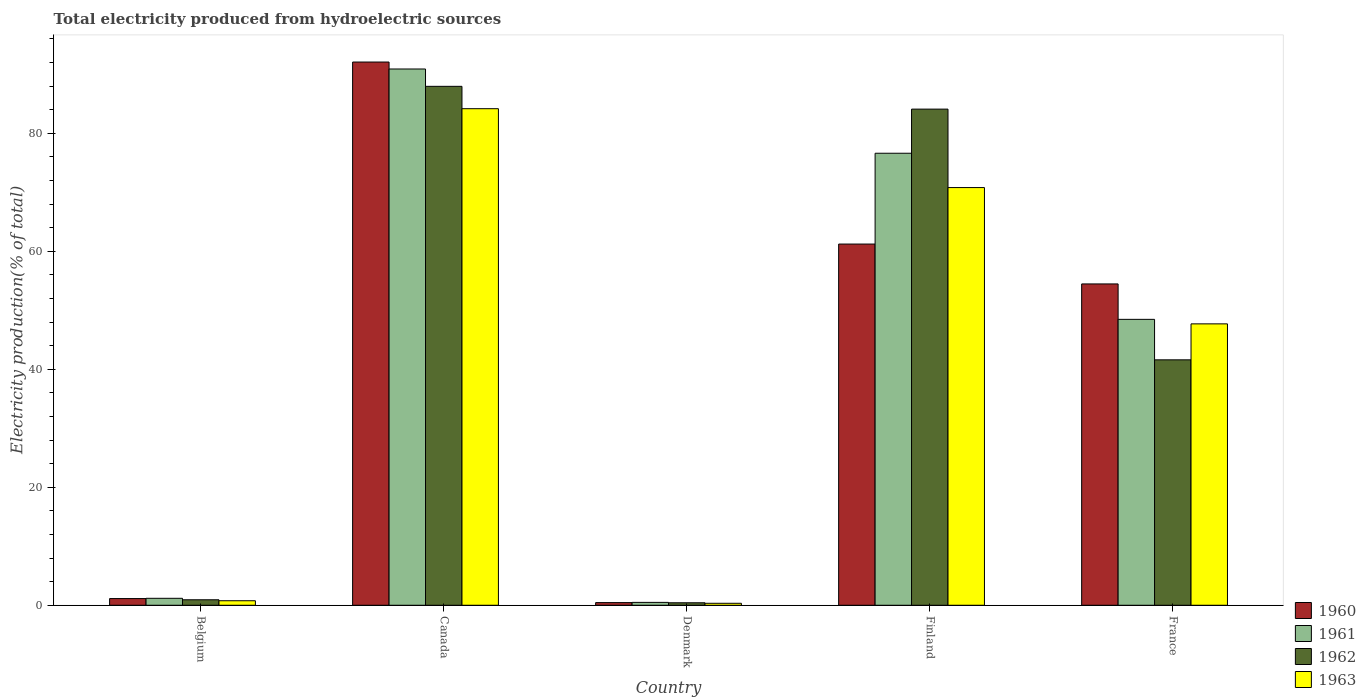How many different coloured bars are there?
Offer a terse response. 4. How many groups of bars are there?
Keep it short and to the point. 5. Are the number of bars on each tick of the X-axis equal?
Give a very brief answer. Yes. How many bars are there on the 1st tick from the right?
Ensure brevity in your answer.  4. What is the total electricity produced in 1963 in Finland?
Your answer should be very brief. 70.81. Across all countries, what is the maximum total electricity produced in 1962?
Provide a short and direct response. 87.97. Across all countries, what is the minimum total electricity produced in 1962?
Offer a very short reply. 0.42. In which country was the total electricity produced in 1961 maximum?
Your answer should be very brief. Canada. In which country was the total electricity produced in 1963 minimum?
Make the answer very short. Denmark. What is the total total electricity produced in 1960 in the graph?
Your response must be concise. 209.38. What is the difference between the total electricity produced in 1961 in Belgium and that in France?
Keep it short and to the point. -47.29. What is the difference between the total electricity produced in 1960 in Denmark and the total electricity produced in 1963 in Canada?
Your answer should be compact. -83.73. What is the average total electricity produced in 1962 per country?
Offer a very short reply. 43.01. What is the difference between the total electricity produced of/in 1962 and total electricity produced of/in 1961 in France?
Keep it short and to the point. -6.86. In how many countries, is the total electricity produced in 1963 greater than 72 %?
Your answer should be compact. 1. What is the ratio of the total electricity produced in 1961 in Canada to that in Finland?
Ensure brevity in your answer.  1.19. What is the difference between the highest and the second highest total electricity produced in 1962?
Offer a terse response. -42.5. What is the difference between the highest and the lowest total electricity produced in 1960?
Your answer should be compact. 91.64. In how many countries, is the total electricity produced in 1961 greater than the average total electricity produced in 1961 taken over all countries?
Provide a succinct answer. 3. Is the sum of the total electricity produced in 1961 in Canada and Denmark greater than the maximum total electricity produced in 1963 across all countries?
Offer a very short reply. Yes. Is it the case that in every country, the sum of the total electricity produced in 1961 and total electricity produced in 1962 is greater than the sum of total electricity produced in 1963 and total electricity produced in 1960?
Your answer should be compact. No. What does the 3rd bar from the left in Canada represents?
Make the answer very short. 1962. What does the 4th bar from the right in Finland represents?
Keep it short and to the point. 1960. Is it the case that in every country, the sum of the total electricity produced in 1960 and total electricity produced in 1962 is greater than the total electricity produced in 1963?
Offer a terse response. Yes. Does the graph contain grids?
Your response must be concise. No. How many legend labels are there?
Provide a succinct answer. 4. What is the title of the graph?
Ensure brevity in your answer.  Total electricity produced from hydroelectric sources. Does "1998" appear as one of the legend labels in the graph?
Keep it short and to the point. No. What is the Electricity production(% of total) in 1960 in Belgium?
Your answer should be compact. 1.14. What is the Electricity production(% of total) in 1961 in Belgium?
Make the answer very short. 1.18. What is the Electricity production(% of total) of 1962 in Belgium?
Offer a very short reply. 0.93. What is the Electricity production(% of total) in 1963 in Belgium?
Your answer should be compact. 0.77. What is the Electricity production(% of total) in 1960 in Canada?
Make the answer very short. 92.09. What is the Electricity production(% of total) of 1961 in Canada?
Give a very brief answer. 90.91. What is the Electricity production(% of total) in 1962 in Canada?
Provide a succinct answer. 87.97. What is the Electricity production(% of total) in 1963 in Canada?
Offer a terse response. 84.18. What is the Electricity production(% of total) in 1960 in Denmark?
Make the answer very short. 0.45. What is the Electricity production(% of total) in 1961 in Denmark?
Keep it short and to the point. 0.49. What is the Electricity production(% of total) of 1962 in Denmark?
Keep it short and to the point. 0.42. What is the Electricity production(% of total) of 1963 in Denmark?
Make the answer very short. 0.33. What is the Electricity production(% of total) in 1960 in Finland?
Your answer should be compact. 61.23. What is the Electricity production(% of total) in 1961 in Finland?
Keep it short and to the point. 76.63. What is the Electricity production(% of total) in 1962 in Finland?
Offer a terse response. 84.11. What is the Electricity production(% of total) of 1963 in Finland?
Ensure brevity in your answer.  70.81. What is the Electricity production(% of total) in 1960 in France?
Give a very brief answer. 54.47. What is the Electricity production(% of total) of 1961 in France?
Ensure brevity in your answer.  48.47. What is the Electricity production(% of total) of 1962 in France?
Ensure brevity in your answer.  41.61. What is the Electricity production(% of total) of 1963 in France?
Provide a succinct answer. 47.7. Across all countries, what is the maximum Electricity production(% of total) in 1960?
Make the answer very short. 92.09. Across all countries, what is the maximum Electricity production(% of total) of 1961?
Offer a very short reply. 90.91. Across all countries, what is the maximum Electricity production(% of total) in 1962?
Offer a terse response. 87.97. Across all countries, what is the maximum Electricity production(% of total) in 1963?
Your answer should be very brief. 84.18. Across all countries, what is the minimum Electricity production(% of total) in 1960?
Your answer should be compact. 0.45. Across all countries, what is the minimum Electricity production(% of total) in 1961?
Make the answer very short. 0.49. Across all countries, what is the minimum Electricity production(% of total) of 1962?
Provide a succinct answer. 0.42. Across all countries, what is the minimum Electricity production(% of total) of 1963?
Your response must be concise. 0.33. What is the total Electricity production(% of total) of 1960 in the graph?
Provide a succinct answer. 209.38. What is the total Electricity production(% of total) of 1961 in the graph?
Your answer should be compact. 217.67. What is the total Electricity production(% of total) in 1962 in the graph?
Provide a short and direct response. 215.03. What is the total Electricity production(% of total) of 1963 in the graph?
Your answer should be compact. 203.79. What is the difference between the Electricity production(% of total) of 1960 in Belgium and that in Canada?
Offer a terse response. -90.95. What is the difference between the Electricity production(% of total) in 1961 in Belgium and that in Canada?
Your response must be concise. -89.73. What is the difference between the Electricity production(% of total) of 1962 in Belgium and that in Canada?
Ensure brevity in your answer.  -87.04. What is the difference between the Electricity production(% of total) in 1963 in Belgium and that in Canada?
Your response must be concise. -83.41. What is the difference between the Electricity production(% of total) in 1960 in Belgium and that in Denmark?
Make the answer very short. 0.68. What is the difference between the Electricity production(% of total) of 1961 in Belgium and that in Denmark?
Your answer should be very brief. 0.69. What is the difference between the Electricity production(% of total) in 1962 in Belgium and that in Denmark?
Give a very brief answer. 0.51. What is the difference between the Electricity production(% of total) in 1963 in Belgium and that in Denmark?
Keep it short and to the point. 0.43. What is the difference between the Electricity production(% of total) of 1960 in Belgium and that in Finland?
Offer a terse response. -60.1. What is the difference between the Electricity production(% of total) of 1961 in Belgium and that in Finland?
Offer a terse response. -75.45. What is the difference between the Electricity production(% of total) of 1962 in Belgium and that in Finland?
Offer a terse response. -83.18. What is the difference between the Electricity production(% of total) of 1963 in Belgium and that in Finland?
Make the answer very short. -70.04. What is the difference between the Electricity production(% of total) of 1960 in Belgium and that in France?
Your answer should be very brief. -53.34. What is the difference between the Electricity production(% of total) of 1961 in Belgium and that in France?
Offer a very short reply. -47.29. What is the difference between the Electricity production(% of total) in 1962 in Belgium and that in France?
Give a very brief answer. -40.68. What is the difference between the Electricity production(% of total) of 1963 in Belgium and that in France?
Your answer should be very brief. -46.94. What is the difference between the Electricity production(% of total) in 1960 in Canada and that in Denmark?
Provide a succinct answer. 91.64. What is the difference between the Electricity production(% of total) in 1961 in Canada and that in Denmark?
Ensure brevity in your answer.  90.42. What is the difference between the Electricity production(% of total) of 1962 in Canada and that in Denmark?
Your answer should be compact. 87.55. What is the difference between the Electricity production(% of total) of 1963 in Canada and that in Denmark?
Give a very brief answer. 83.84. What is the difference between the Electricity production(% of total) of 1960 in Canada and that in Finland?
Provide a succinct answer. 30.86. What is the difference between the Electricity production(% of total) of 1961 in Canada and that in Finland?
Ensure brevity in your answer.  14.28. What is the difference between the Electricity production(% of total) in 1962 in Canada and that in Finland?
Your response must be concise. 3.86. What is the difference between the Electricity production(% of total) of 1963 in Canada and that in Finland?
Your answer should be very brief. 13.37. What is the difference between the Electricity production(% of total) of 1960 in Canada and that in France?
Give a very brief answer. 37.62. What is the difference between the Electricity production(% of total) of 1961 in Canada and that in France?
Your answer should be very brief. 42.44. What is the difference between the Electricity production(% of total) of 1962 in Canada and that in France?
Make the answer very short. 46.36. What is the difference between the Electricity production(% of total) of 1963 in Canada and that in France?
Your answer should be very brief. 36.48. What is the difference between the Electricity production(% of total) of 1960 in Denmark and that in Finland?
Keep it short and to the point. -60.78. What is the difference between the Electricity production(% of total) of 1961 in Denmark and that in Finland?
Ensure brevity in your answer.  -76.14. What is the difference between the Electricity production(% of total) in 1962 in Denmark and that in Finland?
Your response must be concise. -83.69. What is the difference between the Electricity production(% of total) in 1963 in Denmark and that in Finland?
Ensure brevity in your answer.  -70.47. What is the difference between the Electricity production(% of total) of 1960 in Denmark and that in France?
Offer a very short reply. -54.02. What is the difference between the Electricity production(% of total) of 1961 in Denmark and that in France?
Provide a short and direct response. -47.98. What is the difference between the Electricity production(% of total) of 1962 in Denmark and that in France?
Provide a succinct answer. -41.18. What is the difference between the Electricity production(% of total) in 1963 in Denmark and that in France?
Provide a short and direct response. -47.37. What is the difference between the Electricity production(% of total) in 1960 in Finland and that in France?
Ensure brevity in your answer.  6.76. What is the difference between the Electricity production(% of total) of 1961 in Finland and that in France?
Provide a succinct answer. 28.16. What is the difference between the Electricity production(% of total) of 1962 in Finland and that in France?
Ensure brevity in your answer.  42.5. What is the difference between the Electricity production(% of total) of 1963 in Finland and that in France?
Offer a very short reply. 23.11. What is the difference between the Electricity production(% of total) of 1960 in Belgium and the Electricity production(% of total) of 1961 in Canada?
Offer a terse response. -89.78. What is the difference between the Electricity production(% of total) in 1960 in Belgium and the Electricity production(% of total) in 1962 in Canada?
Your answer should be compact. -86.83. What is the difference between the Electricity production(% of total) in 1960 in Belgium and the Electricity production(% of total) in 1963 in Canada?
Ensure brevity in your answer.  -83.04. What is the difference between the Electricity production(% of total) in 1961 in Belgium and the Electricity production(% of total) in 1962 in Canada?
Give a very brief answer. -86.79. What is the difference between the Electricity production(% of total) in 1961 in Belgium and the Electricity production(% of total) in 1963 in Canada?
Your answer should be very brief. -83. What is the difference between the Electricity production(% of total) of 1962 in Belgium and the Electricity production(% of total) of 1963 in Canada?
Your answer should be very brief. -83.25. What is the difference between the Electricity production(% of total) of 1960 in Belgium and the Electricity production(% of total) of 1961 in Denmark?
Make the answer very short. 0.65. What is the difference between the Electricity production(% of total) of 1960 in Belgium and the Electricity production(% of total) of 1962 in Denmark?
Offer a very short reply. 0.71. What is the difference between the Electricity production(% of total) of 1960 in Belgium and the Electricity production(% of total) of 1963 in Denmark?
Offer a very short reply. 0.8. What is the difference between the Electricity production(% of total) of 1961 in Belgium and the Electricity production(% of total) of 1962 in Denmark?
Make the answer very short. 0.76. What is the difference between the Electricity production(% of total) in 1961 in Belgium and the Electricity production(% of total) in 1963 in Denmark?
Provide a short and direct response. 0.84. What is the difference between the Electricity production(% of total) of 1962 in Belgium and the Electricity production(% of total) of 1963 in Denmark?
Ensure brevity in your answer.  0.59. What is the difference between the Electricity production(% of total) in 1960 in Belgium and the Electricity production(% of total) in 1961 in Finland?
Your response must be concise. -75.49. What is the difference between the Electricity production(% of total) in 1960 in Belgium and the Electricity production(% of total) in 1962 in Finland?
Your response must be concise. -82.97. What is the difference between the Electricity production(% of total) of 1960 in Belgium and the Electricity production(% of total) of 1963 in Finland?
Give a very brief answer. -69.67. What is the difference between the Electricity production(% of total) in 1961 in Belgium and the Electricity production(% of total) in 1962 in Finland?
Provide a short and direct response. -82.93. What is the difference between the Electricity production(% of total) in 1961 in Belgium and the Electricity production(% of total) in 1963 in Finland?
Keep it short and to the point. -69.63. What is the difference between the Electricity production(% of total) of 1962 in Belgium and the Electricity production(% of total) of 1963 in Finland?
Your response must be concise. -69.88. What is the difference between the Electricity production(% of total) of 1960 in Belgium and the Electricity production(% of total) of 1961 in France?
Provide a short and direct response. -47.33. What is the difference between the Electricity production(% of total) of 1960 in Belgium and the Electricity production(% of total) of 1962 in France?
Your response must be concise. -40.47. What is the difference between the Electricity production(% of total) of 1960 in Belgium and the Electricity production(% of total) of 1963 in France?
Your answer should be compact. -46.57. What is the difference between the Electricity production(% of total) in 1961 in Belgium and the Electricity production(% of total) in 1962 in France?
Provide a short and direct response. -40.43. What is the difference between the Electricity production(% of total) of 1961 in Belgium and the Electricity production(% of total) of 1963 in France?
Offer a very short reply. -46.52. What is the difference between the Electricity production(% of total) of 1962 in Belgium and the Electricity production(% of total) of 1963 in France?
Your answer should be very brief. -46.77. What is the difference between the Electricity production(% of total) in 1960 in Canada and the Electricity production(% of total) in 1961 in Denmark?
Make the answer very short. 91.6. What is the difference between the Electricity production(% of total) in 1960 in Canada and the Electricity production(% of total) in 1962 in Denmark?
Give a very brief answer. 91.67. What is the difference between the Electricity production(% of total) of 1960 in Canada and the Electricity production(% of total) of 1963 in Denmark?
Provide a short and direct response. 91.75. What is the difference between the Electricity production(% of total) in 1961 in Canada and the Electricity production(% of total) in 1962 in Denmark?
Make the answer very short. 90.49. What is the difference between the Electricity production(% of total) of 1961 in Canada and the Electricity production(% of total) of 1963 in Denmark?
Your answer should be very brief. 90.58. What is the difference between the Electricity production(% of total) of 1962 in Canada and the Electricity production(% of total) of 1963 in Denmark?
Your answer should be compact. 87.63. What is the difference between the Electricity production(% of total) of 1960 in Canada and the Electricity production(% of total) of 1961 in Finland?
Offer a very short reply. 15.46. What is the difference between the Electricity production(% of total) in 1960 in Canada and the Electricity production(% of total) in 1962 in Finland?
Provide a succinct answer. 7.98. What is the difference between the Electricity production(% of total) in 1960 in Canada and the Electricity production(% of total) in 1963 in Finland?
Keep it short and to the point. 21.28. What is the difference between the Electricity production(% of total) of 1961 in Canada and the Electricity production(% of total) of 1962 in Finland?
Offer a terse response. 6.8. What is the difference between the Electricity production(% of total) of 1961 in Canada and the Electricity production(% of total) of 1963 in Finland?
Provide a succinct answer. 20.1. What is the difference between the Electricity production(% of total) of 1962 in Canada and the Electricity production(% of total) of 1963 in Finland?
Give a very brief answer. 17.16. What is the difference between the Electricity production(% of total) of 1960 in Canada and the Electricity production(% of total) of 1961 in France?
Keep it short and to the point. 43.62. What is the difference between the Electricity production(% of total) of 1960 in Canada and the Electricity production(% of total) of 1962 in France?
Provide a short and direct response. 50.48. What is the difference between the Electricity production(% of total) of 1960 in Canada and the Electricity production(% of total) of 1963 in France?
Ensure brevity in your answer.  44.39. What is the difference between the Electricity production(% of total) in 1961 in Canada and the Electricity production(% of total) in 1962 in France?
Give a very brief answer. 49.3. What is the difference between the Electricity production(% of total) of 1961 in Canada and the Electricity production(% of total) of 1963 in France?
Your response must be concise. 43.21. What is the difference between the Electricity production(% of total) of 1962 in Canada and the Electricity production(% of total) of 1963 in France?
Your answer should be very brief. 40.27. What is the difference between the Electricity production(% of total) in 1960 in Denmark and the Electricity production(% of total) in 1961 in Finland?
Provide a short and direct response. -76.18. What is the difference between the Electricity production(% of total) of 1960 in Denmark and the Electricity production(% of total) of 1962 in Finland?
Offer a very short reply. -83.66. What is the difference between the Electricity production(% of total) of 1960 in Denmark and the Electricity production(% of total) of 1963 in Finland?
Offer a terse response. -70.36. What is the difference between the Electricity production(% of total) of 1961 in Denmark and the Electricity production(% of total) of 1962 in Finland?
Keep it short and to the point. -83.62. What is the difference between the Electricity production(% of total) of 1961 in Denmark and the Electricity production(% of total) of 1963 in Finland?
Your answer should be compact. -70.32. What is the difference between the Electricity production(% of total) in 1962 in Denmark and the Electricity production(% of total) in 1963 in Finland?
Provide a succinct answer. -70.39. What is the difference between the Electricity production(% of total) of 1960 in Denmark and the Electricity production(% of total) of 1961 in France?
Make the answer very short. -48.02. What is the difference between the Electricity production(% of total) in 1960 in Denmark and the Electricity production(% of total) in 1962 in France?
Give a very brief answer. -41.15. What is the difference between the Electricity production(% of total) of 1960 in Denmark and the Electricity production(% of total) of 1963 in France?
Offer a terse response. -47.25. What is the difference between the Electricity production(% of total) in 1961 in Denmark and the Electricity production(% of total) in 1962 in France?
Make the answer very short. -41.12. What is the difference between the Electricity production(% of total) in 1961 in Denmark and the Electricity production(% of total) in 1963 in France?
Your answer should be compact. -47.21. What is the difference between the Electricity production(% of total) of 1962 in Denmark and the Electricity production(% of total) of 1963 in France?
Your answer should be compact. -47.28. What is the difference between the Electricity production(% of total) in 1960 in Finland and the Electricity production(% of total) in 1961 in France?
Your answer should be very brief. 12.76. What is the difference between the Electricity production(% of total) of 1960 in Finland and the Electricity production(% of total) of 1962 in France?
Provide a succinct answer. 19.63. What is the difference between the Electricity production(% of total) of 1960 in Finland and the Electricity production(% of total) of 1963 in France?
Your response must be concise. 13.53. What is the difference between the Electricity production(% of total) in 1961 in Finland and the Electricity production(% of total) in 1962 in France?
Offer a very short reply. 35.02. What is the difference between the Electricity production(% of total) of 1961 in Finland and the Electricity production(% of total) of 1963 in France?
Offer a very short reply. 28.93. What is the difference between the Electricity production(% of total) in 1962 in Finland and the Electricity production(% of total) in 1963 in France?
Your answer should be very brief. 36.41. What is the average Electricity production(% of total) in 1960 per country?
Keep it short and to the point. 41.88. What is the average Electricity production(% of total) in 1961 per country?
Your answer should be very brief. 43.53. What is the average Electricity production(% of total) in 1962 per country?
Your answer should be compact. 43.01. What is the average Electricity production(% of total) in 1963 per country?
Offer a very short reply. 40.76. What is the difference between the Electricity production(% of total) in 1960 and Electricity production(% of total) in 1961 in Belgium?
Make the answer very short. -0.04. What is the difference between the Electricity production(% of total) of 1960 and Electricity production(% of total) of 1962 in Belgium?
Keep it short and to the point. 0.21. What is the difference between the Electricity production(% of total) of 1960 and Electricity production(% of total) of 1963 in Belgium?
Your answer should be very brief. 0.37. What is the difference between the Electricity production(% of total) of 1961 and Electricity production(% of total) of 1962 in Belgium?
Give a very brief answer. 0.25. What is the difference between the Electricity production(% of total) of 1961 and Electricity production(% of total) of 1963 in Belgium?
Your answer should be compact. 0.41. What is the difference between the Electricity production(% of total) of 1962 and Electricity production(% of total) of 1963 in Belgium?
Ensure brevity in your answer.  0.16. What is the difference between the Electricity production(% of total) in 1960 and Electricity production(% of total) in 1961 in Canada?
Provide a succinct answer. 1.18. What is the difference between the Electricity production(% of total) of 1960 and Electricity production(% of total) of 1962 in Canada?
Give a very brief answer. 4.12. What is the difference between the Electricity production(% of total) in 1960 and Electricity production(% of total) in 1963 in Canada?
Keep it short and to the point. 7.91. What is the difference between the Electricity production(% of total) in 1961 and Electricity production(% of total) in 1962 in Canada?
Make the answer very short. 2.94. What is the difference between the Electricity production(% of total) of 1961 and Electricity production(% of total) of 1963 in Canada?
Make the answer very short. 6.73. What is the difference between the Electricity production(% of total) of 1962 and Electricity production(% of total) of 1963 in Canada?
Give a very brief answer. 3.79. What is the difference between the Electricity production(% of total) of 1960 and Electricity production(% of total) of 1961 in Denmark?
Ensure brevity in your answer.  -0.04. What is the difference between the Electricity production(% of total) of 1960 and Electricity production(% of total) of 1962 in Denmark?
Provide a succinct answer. 0.03. What is the difference between the Electricity production(% of total) in 1960 and Electricity production(% of total) in 1963 in Denmark?
Keep it short and to the point. 0.12. What is the difference between the Electricity production(% of total) of 1961 and Electricity production(% of total) of 1962 in Denmark?
Ensure brevity in your answer.  0.07. What is the difference between the Electricity production(% of total) in 1961 and Electricity production(% of total) in 1963 in Denmark?
Give a very brief answer. 0.15. What is the difference between the Electricity production(% of total) of 1962 and Electricity production(% of total) of 1963 in Denmark?
Your response must be concise. 0.09. What is the difference between the Electricity production(% of total) in 1960 and Electricity production(% of total) in 1961 in Finland?
Offer a very short reply. -15.4. What is the difference between the Electricity production(% of total) in 1960 and Electricity production(% of total) in 1962 in Finland?
Offer a very short reply. -22.88. What is the difference between the Electricity production(% of total) of 1960 and Electricity production(% of total) of 1963 in Finland?
Keep it short and to the point. -9.58. What is the difference between the Electricity production(% of total) in 1961 and Electricity production(% of total) in 1962 in Finland?
Your answer should be very brief. -7.48. What is the difference between the Electricity production(% of total) in 1961 and Electricity production(% of total) in 1963 in Finland?
Give a very brief answer. 5.82. What is the difference between the Electricity production(% of total) in 1962 and Electricity production(% of total) in 1963 in Finland?
Offer a very short reply. 13.3. What is the difference between the Electricity production(% of total) of 1960 and Electricity production(% of total) of 1961 in France?
Keep it short and to the point. 6.01. What is the difference between the Electricity production(% of total) of 1960 and Electricity production(% of total) of 1962 in France?
Your response must be concise. 12.87. What is the difference between the Electricity production(% of total) of 1960 and Electricity production(% of total) of 1963 in France?
Provide a short and direct response. 6.77. What is the difference between the Electricity production(% of total) of 1961 and Electricity production(% of total) of 1962 in France?
Your answer should be compact. 6.86. What is the difference between the Electricity production(% of total) of 1961 and Electricity production(% of total) of 1963 in France?
Provide a succinct answer. 0.77. What is the difference between the Electricity production(% of total) in 1962 and Electricity production(% of total) in 1963 in France?
Your response must be concise. -6.1. What is the ratio of the Electricity production(% of total) of 1960 in Belgium to that in Canada?
Provide a short and direct response. 0.01. What is the ratio of the Electricity production(% of total) of 1961 in Belgium to that in Canada?
Give a very brief answer. 0.01. What is the ratio of the Electricity production(% of total) in 1962 in Belgium to that in Canada?
Offer a very short reply. 0.01. What is the ratio of the Electricity production(% of total) in 1963 in Belgium to that in Canada?
Make the answer very short. 0.01. What is the ratio of the Electricity production(% of total) of 1960 in Belgium to that in Denmark?
Your response must be concise. 2.52. What is the ratio of the Electricity production(% of total) of 1961 in Belgium to that in Denmark?
Your answer should be very brief. 2.41. What is the ratio of the Electricity production(% of total) of 1962 in Belgium to that in Denmark?
Provide a succinct answer. 2.21. What is the ratio of the Electricity production(% of total) in 1963 in Belgium to that in Denmark?
Your response must be concise. 2.29. What is the ratio of the Electricity production(% of total) in 1960 in Belgium to that in Finland?
Offer a terse response. 0.02. What is the ratio of the Electricity production(% of total) in 1961 in Belgium to that in Finland?
Provide a succinct answer. 0.02. What is the ratio of the Electricity production(% of total) of 1962 in Belgium to that in Finland?
Ensure brevity in your answer.  0.01. What is the ratio of the Electricity production(% of total) in 1963 in Belgium to that in Finland?
Give a very brief answer. 0.01. What is the ratio of the Electricity production(% of total) in 1960 in Belgium to that in France?
Ensure brevity in your answer.  0.02. What is the ratio of the Electricity production(% of total) of 1961 in Belgium to that in France?
Provide a succinct answer. 0.02. What is the ratio of the Electricity production(% of total) of 1962 in Belgium to that in France?
Your answer should be compact. 0.02. What is the ratio of the Electricity production(% of total) of 1963 in Belgium to that in France?
Give a very brief answer. 0.02. What is the ratio of the Electricity production(% of total) in 1960 in Canada to that in Denmark?
Offer a very short reply. 204.07. What is the ratio of the Electricity production(% of total) in 1961 in Canada to that in Denmark?
Your response must be concise. 185.88. What is the ratio of the Electricity production(% of total) in 1962 in Canada to that in Denmark?
Offer a terse response. 208.99. What is the ratio of the Electricity production(% of total) of 1963 in Canada to that in Denmark?
Give a very brief answer. 251.69. What is the ratio of the Electricity production(% of total) of 1960 in Canada to that in Finland?
Make the answer very short. 1.5. What is the ratio of the Electricity production(% of total) of 1961 in Canada to that in Finland?
Your answer should be very brief. 1.19. What is the ratio of the Electricity production(% of total) in 1962 in Canada to that in Finland?
Give a very brief answer. 1.05. What is the ratio of the Electricity production(% of total) of 1963 in Canada to that in Finland?
Your answer should be compact. 1.19. What is the ratio of the Electricity production(% of total) of 1960 in Canada to that in France?
Make the answer very short. 1.69. What is the ratio of the Electricity production(% of total) of 1961 in Canada to that in France?
Your answer should be very brief. 1.88. What is the ratio of the Electricity production(% of total) in 1962 in Canada to that in France?
Your answer should be very brief. 2.11. What is the ratio of the Electricity production(% of total) of 1963 in Canada to that in France?
Your response must be concise. 1.76. What is the ratio of the Electricity production(% of total) in 1960 in Denmark to that in Finland?
Your answer should be very brief. 0.01. What is the ratio of the Electricity production(% of total) of 1961 in Denmark to that in Finland?
Provide a succinct answer. 0.01. What is the ratio of the Electricity production(% of total) of 1962 in Denmark to that in Finland?
Your answer should be compact. 0.01. What is the ratio of the Electricity production(% of total) of 1963 in Denmark to that in Finland?
Provide a short and direct response. 0. What is the ratio of the Electricity production(% of total) in 1960 in Denmark to that in France?
Your response must be concise. 0.01. What is the ratio of the Electricity production(% of total) of 1961 in Denmark to that in France?
Offer a terse response. 0.01. What is the ratio of the Electricity production(% of total) in 1962 in Denmark to that in France?
Provide a succinct answer. 0.01. What is the ratio of the Electricity production(% of total) of 1963 in Denmark to that in France?
Offer a very short reply. 0.01. What is the ratio of the Electricity production(% of total) in 1960 in Finland to that in France?
Your answer should be compact. 1.12. What is the ratio of the Electricity production(% of total) in 1961 in Finland to that in France?
Make the answer very short. 1.58. What is the ratio of the Electricity production(% of total) in 1962 in Finland to that in France?
Offer a terse response. 2.02. What is the ratio of the Electricity production(% of total) in 1963 in Finland to that in France?
Your answer should be compact. 1.48. What is the difference between the highest and the second highest Electricity production(% of total) in 1960?
Make the answer very short. 30.86. What is the difference between the highest and the second highest Electricity production(% of total) in 1961?
Make the answer very short. 14.28. What is the difference between the highest and the second highest Electricity production(% of total) in 1962?
Provide a succinct answer. 3.86. What is the difference between the highest and the second highest Electricity production(% of total) of 1963?
Give a very brief answer. 13.37. What is the difference between the highest and the lowest Electricity production(% of total) in 1960?
Provide a short and direct response. 91.64. What is the difference between the highest and the lowest Electricity production(% of total) in 1961?
Offer a very short reply. 90.42. What is the difference between the highest and the lowest Electricity production(% of total) in 1962?
Your response must be concise. 87.55. What is the difference between the highest and the lowest Electricity production(% of total) in 1963?
Offer a very short reply. 83.84. 